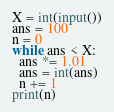Convert code to text. <code><loc_0><loc_0><loc_500><loc_500><_Python_>X = int(input())
ans = 100
n = 0
while ans < X:
  ans *= 1.01
  ans = int(ans)
  n += 1
print(n)</code> 